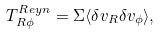<formula> <loc_0><loc_0><loc_500><loc_500>T _ { R \phi } ^ { R e y n } = \Sigma \langle \delta v _ { R } \delta v _ { \phi } \rangle ,</formula> 